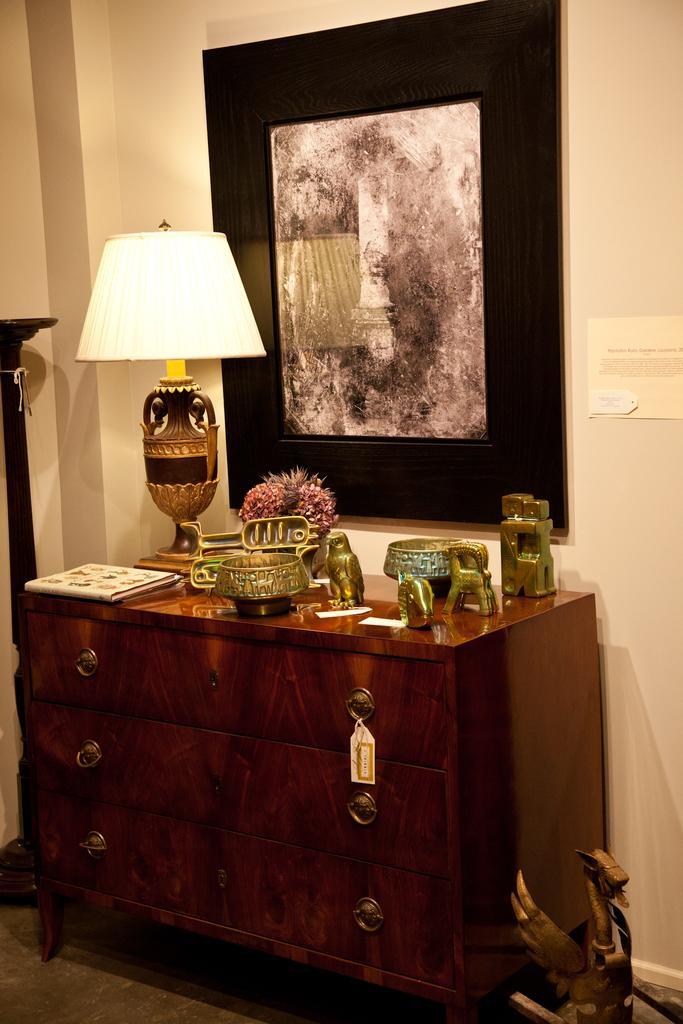In one or two sentences, can you explain what this image depicts? In this image we can see a lamp, flower vase and some toys on the cupboard and at the background of the image there is some painting attached to the wall and there is wall. 